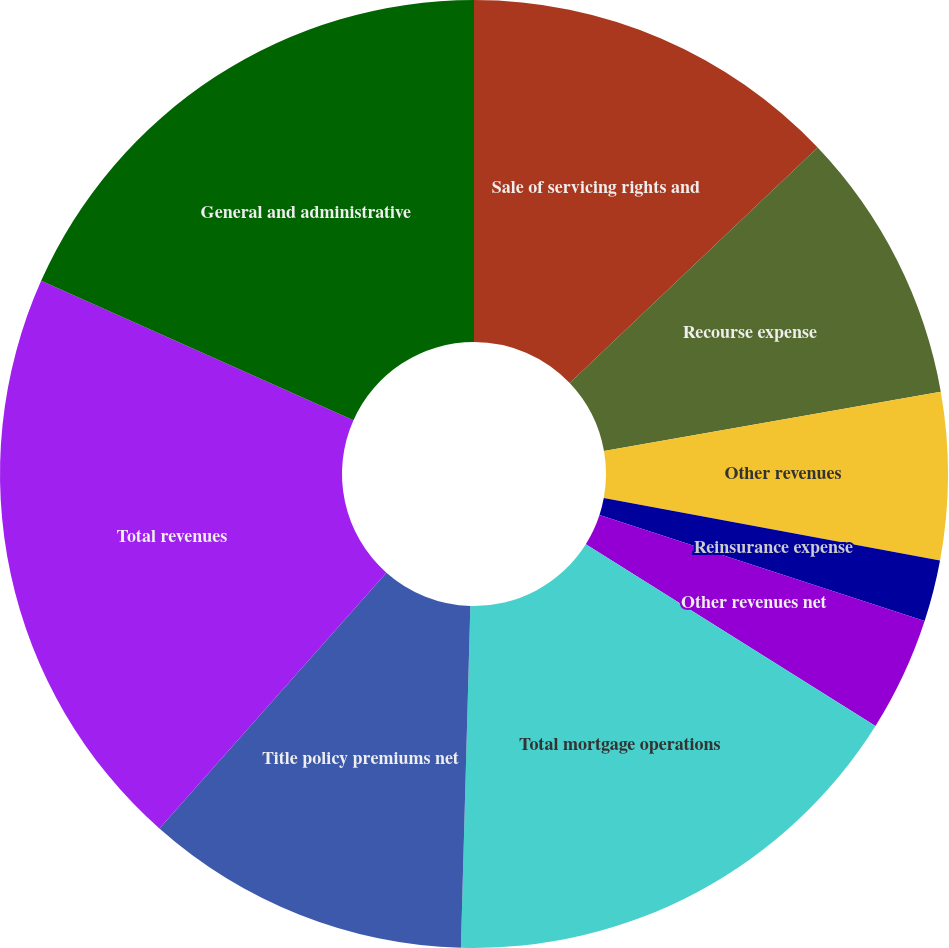<chart> <loc_0><loc_0><loc_500><loc_500><pie_chart><fcel>Sale of servicing rights and<fcel>Recourse expense<fcel>Other revenues<fcel>Reinsurance expense<fcel>Other revenues net<fcel>Total mortgage operations<fcel>Title policy premiums net<fcel>Total revenues<fcel>General and administrative<nl><fcel>12.91%<fcel>9.31%<fcel>5.7%<fcel>2.1%<fcel>3.9%<fcel>16.52%<fcel>11.11%<fcel>20.13%<fcel>18.32%<nl></chart> 